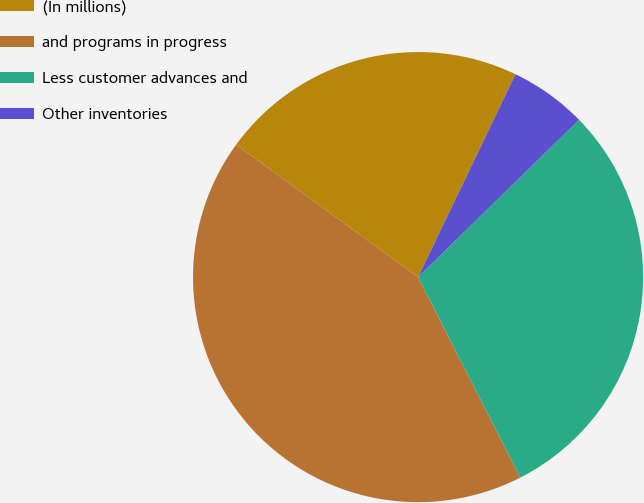Convert chart. <chart><loc_0><loc_0><loc_500><loc_500><pie_chart><fcel>(In millions)<fcel>and programs in progress<fcel>Less customer advances and<fcel>Other inventories<nl><fcel>22.11%<fcel>42.52%<fcel>29.81%<fcel>5.56%<nl></chart> 